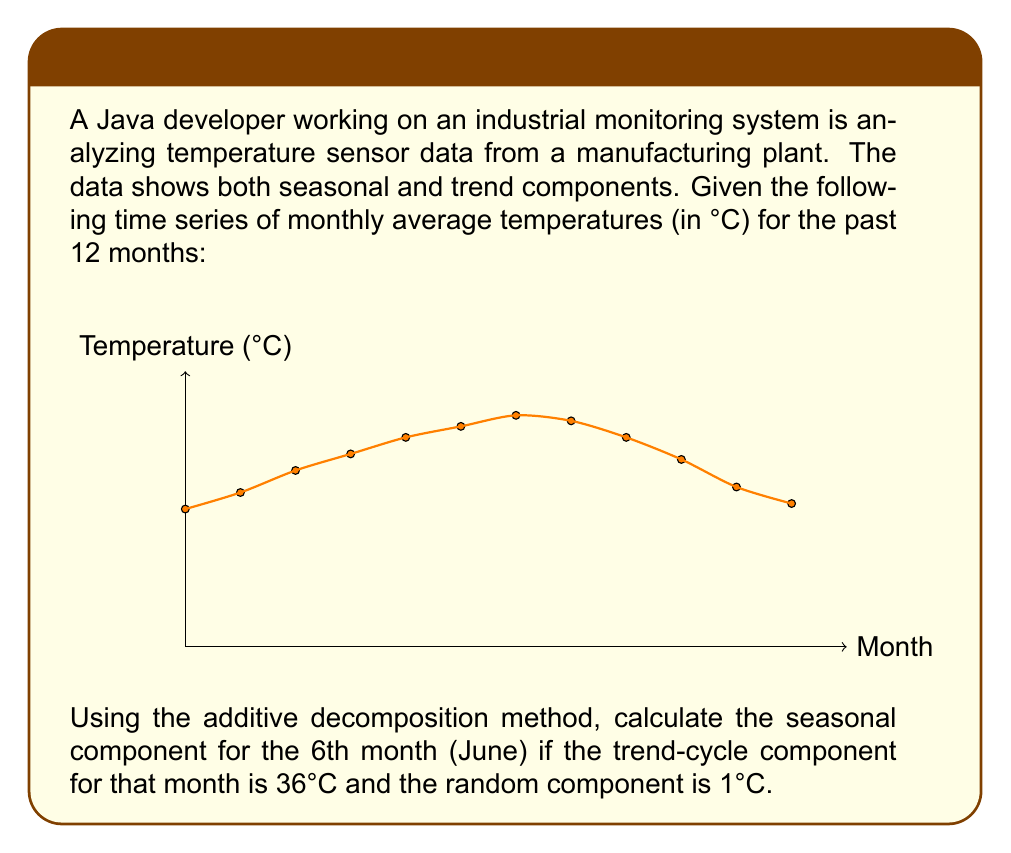What is the answer to this math problem? To solve this problem, we'll use the additive decomposition method for time series analysis. The additive model is represented as:

$$Y_t = T_t + S_t + R_t$$

Where:
$Y_t$ is the observed value
$T_t$ is the trend-cycle component
$S_t$ is the seasonal component
$R_t$ is the random (irregular) component

We are given:
1. $Y_t$ (observed value) for June (6th month) = 40°C (from the graph)
2. $T_t$ (trend-cycle component) for June = 36°C
3. $R_t$ (random component) for June = 1°C

To find the seasonal component $S_t$, we rearrange the equation:

$$S_t = Y_t - T_t - R_t$$

Substituting the known values:

$$S_t = 40°C - 36°C - 1°C$$

$$S_t = 3°C$$

Therefore, the seasonal component for June is 3°C.
Answer: 3°C 